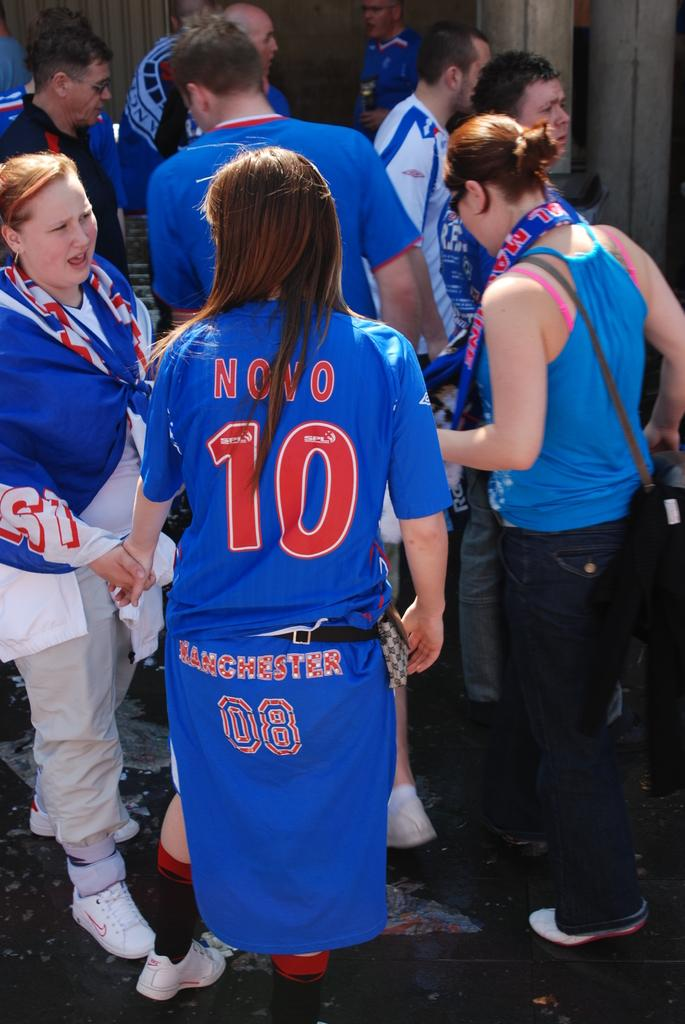<image>
Provide a brief description of the given image. A woman has the number ten on the back of her shirt. 